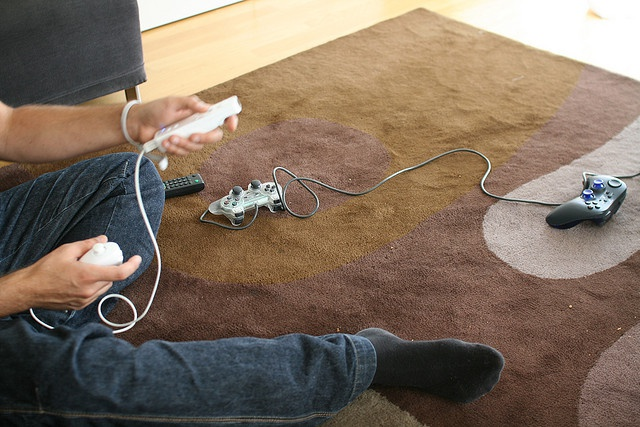Describe the objects in this image and their specific colors. I can see people in black, blue, and gray tones, couch in black, gray, and purple tones, remote in black, gray, lightgray, and darkgray tones, remote in black, lightgray, darkgray, and gray tones, and remote in black, white, darkgray, tan, and lightgray tones in this image. 